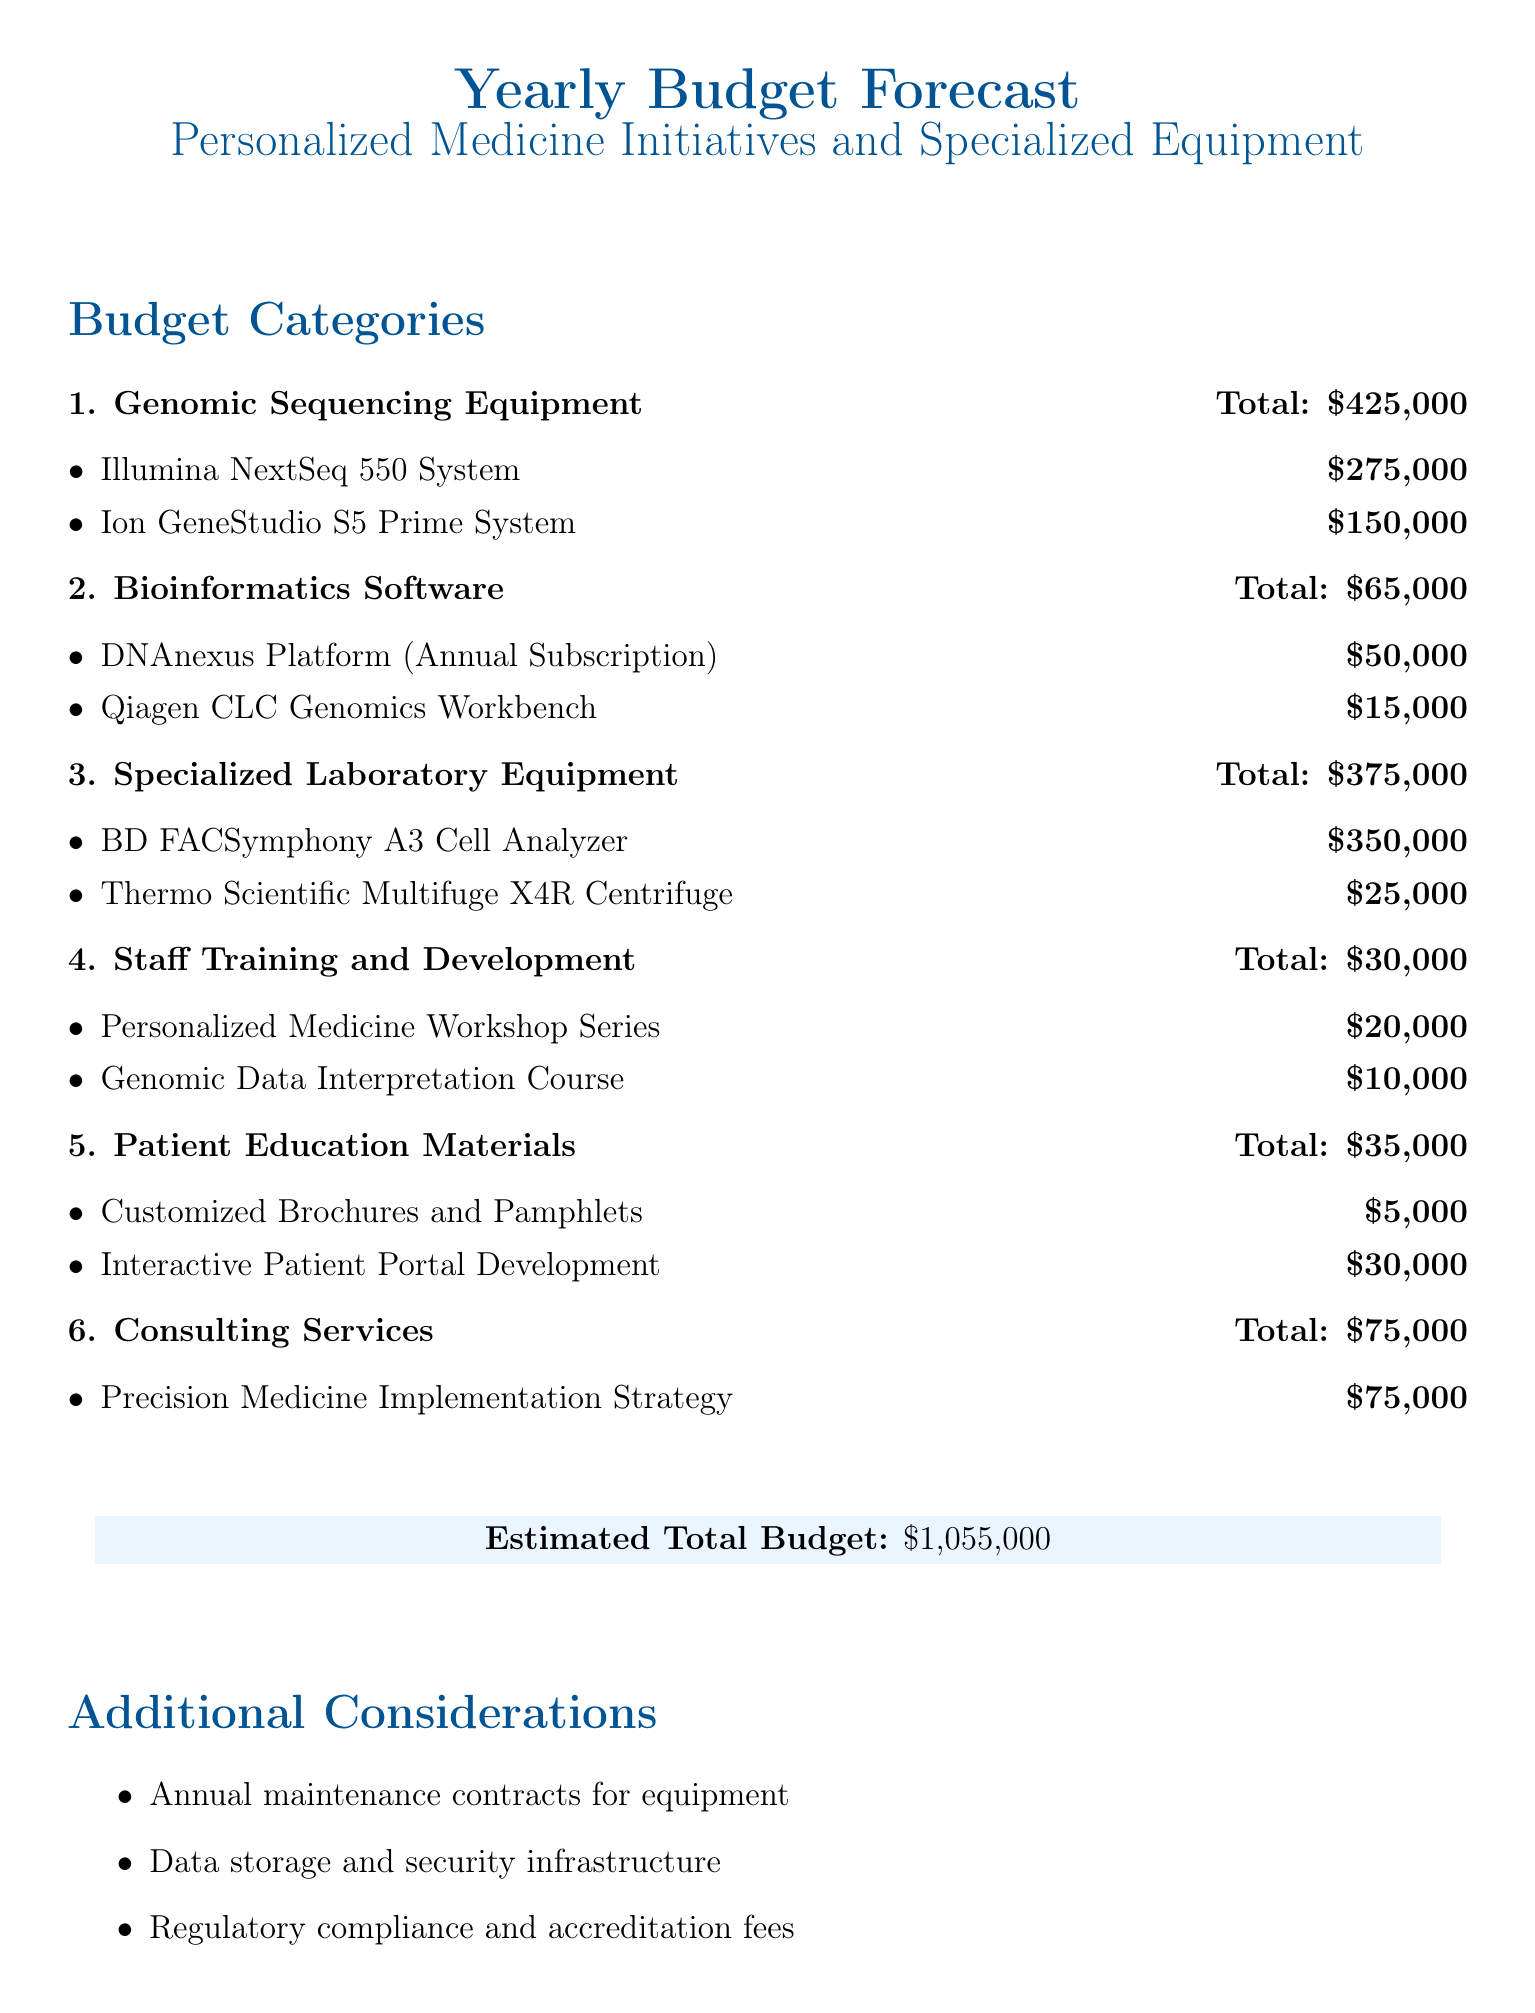What is the total budget for Genomic Sequencing Equipment? The total budget for Genomic Sequencing Equipment is provided in the document under its category.
Answer: $425,000 How much is allocated for the BD FACSymphony A3 Cell Analyzer? The document lists the cost specifically for the BD FACSymphony A3 Cell Analyzer under Specialized Laboratory Equipment.
Answer: $350,000 What is the cost of the DNAnexus Platform? The document specifies the annual subscription cost for the DNAnexus Platform under Bioinformatics Software.
Answer: $50,000 How much is set aside for Staff Training and Development? The budget shows the total amount allocated for Staff Training and Development in its respective category.
Answer: $30,000 What is the estimated total budget? The document summarizes the overall financial estimate at the end under the total budget section.
Answer: $1,055,000 What is included in the Patient Education Materials budget? The budget provides specific items under Patient Education Materials, which includes customized brochures and an interactive portal.
Answer: $35,000 How much is allocated for the Personalized Medicine Workshop Series? The document details the budget for the workshop series as part of staff training.
Answer: $20,000 What consulting service is included in the budget? The document specifies the consulting service listed under Consulting Services.
Answer: Precision Medicine Implementation Strategy What additional considerations are mentioned in the document? The document lists specific additional considerations related to ongoing operations and compliance after presenting the budget.
Answer: Annual maintenance contracts, data storage, regulatory compliance 